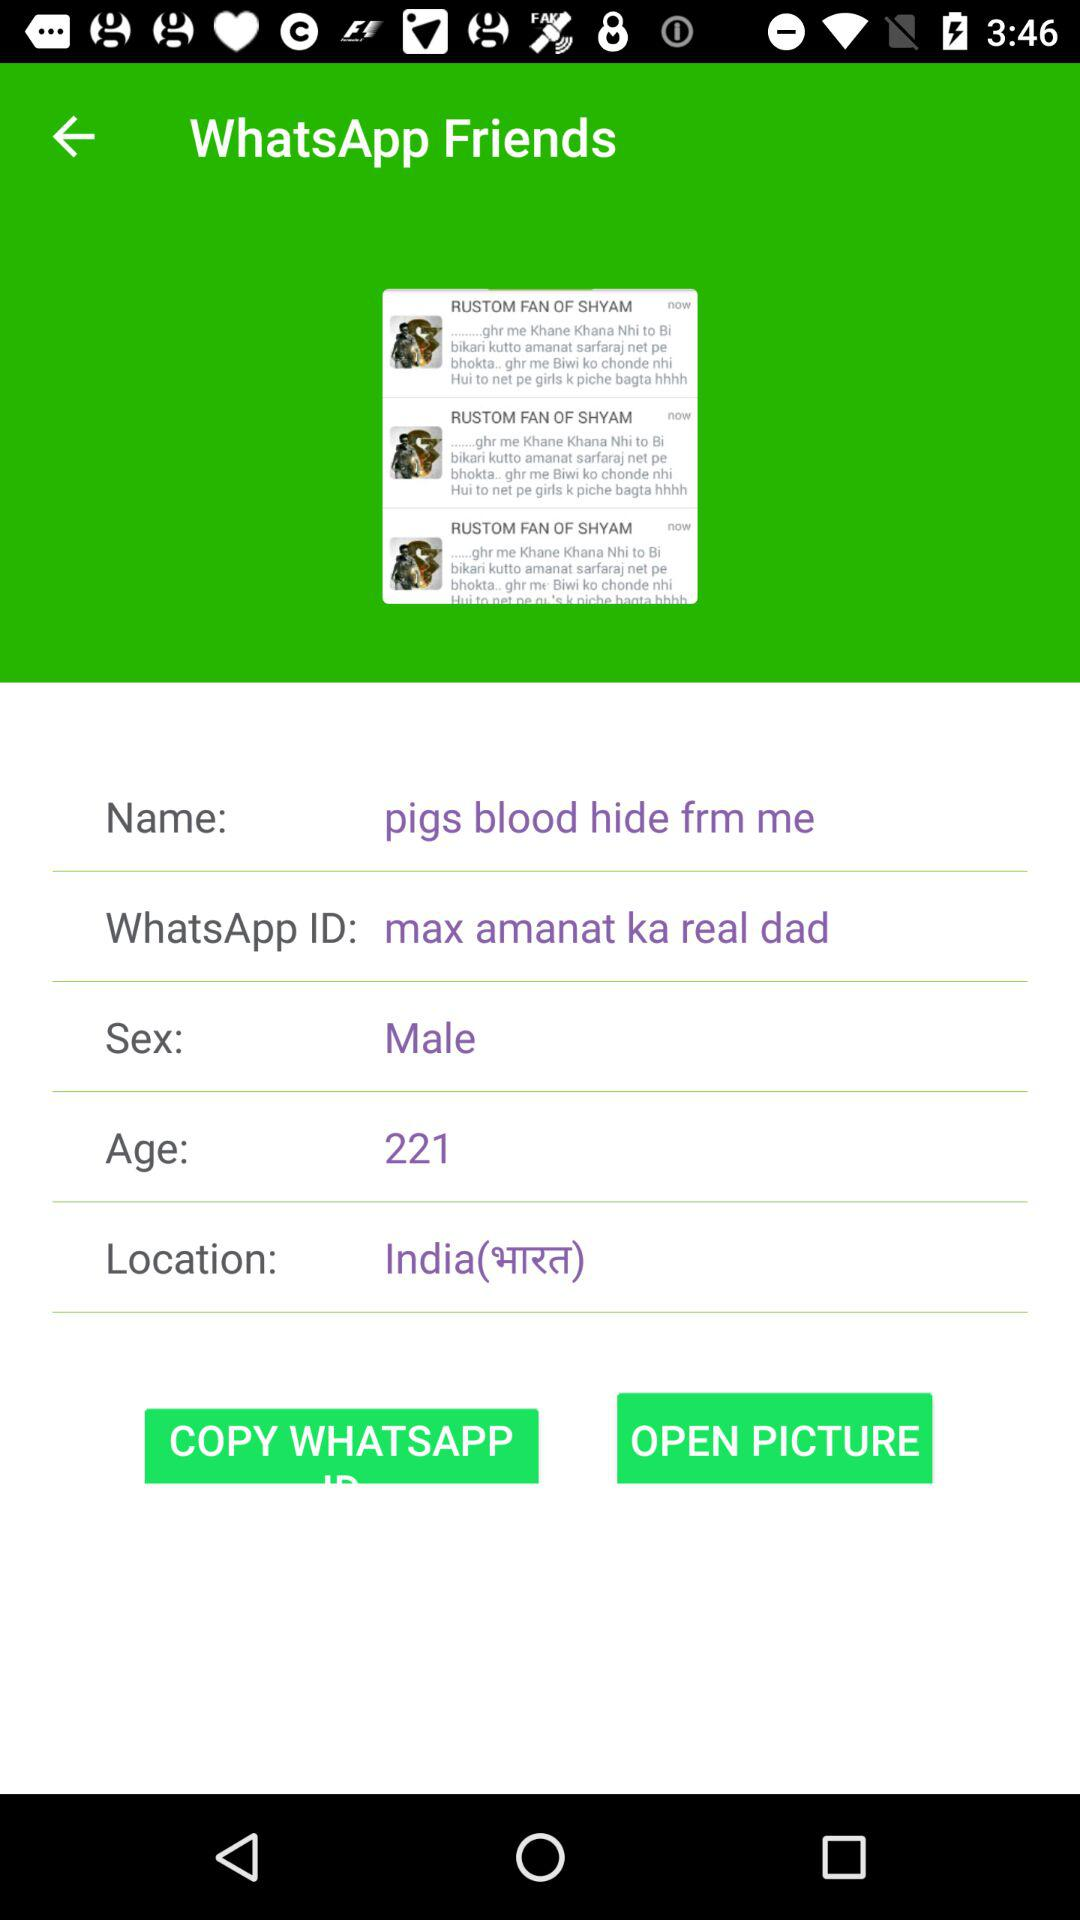What is the selected location? The selected location is India. 